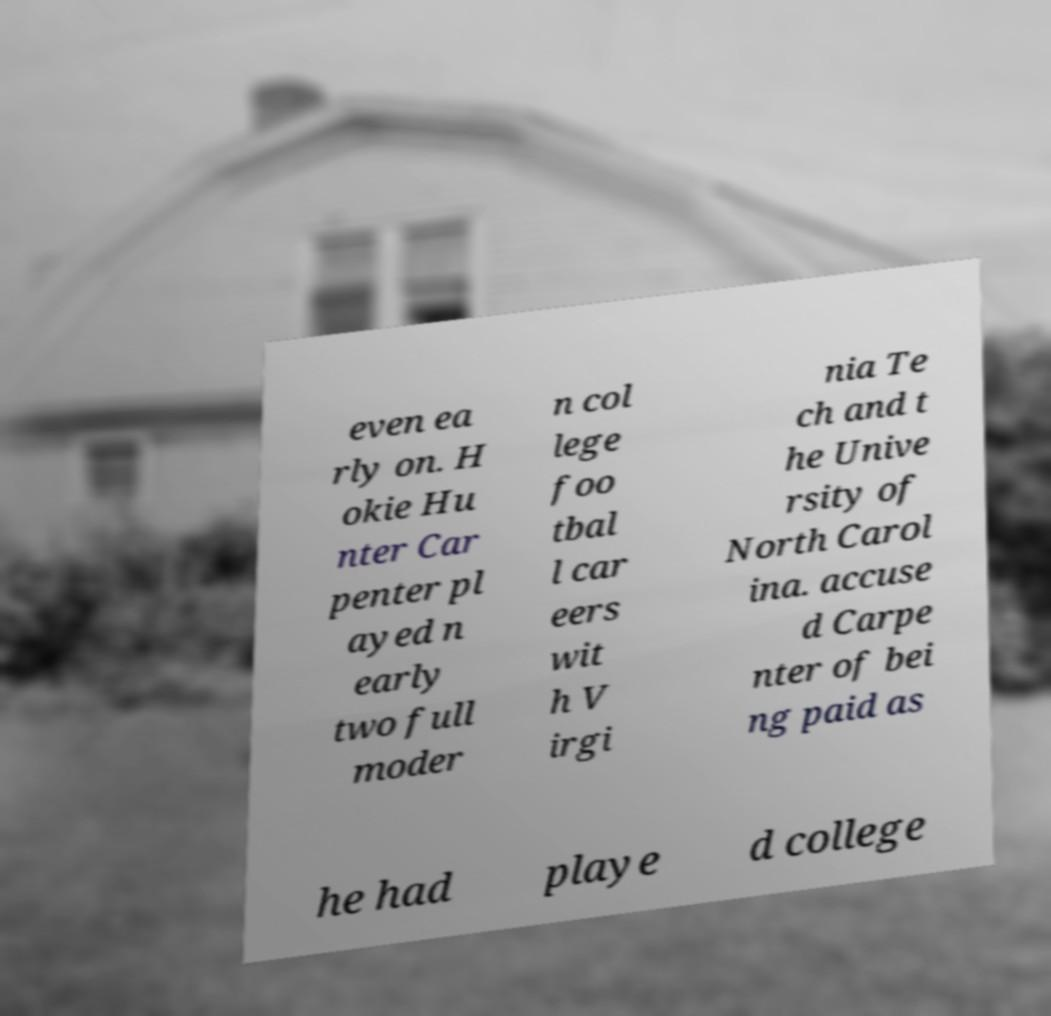I need the written content from this picture converted into text. Can you do that? even ea rly on. H okie Hu nter Car penter pl ayed n early two full moder n col lege foo tbal l car eers wit h V irgi nia Te ch and t he Unive rsity of North Carol ina. accuse d Carpe nter of bei ng paid as he had playe d college 